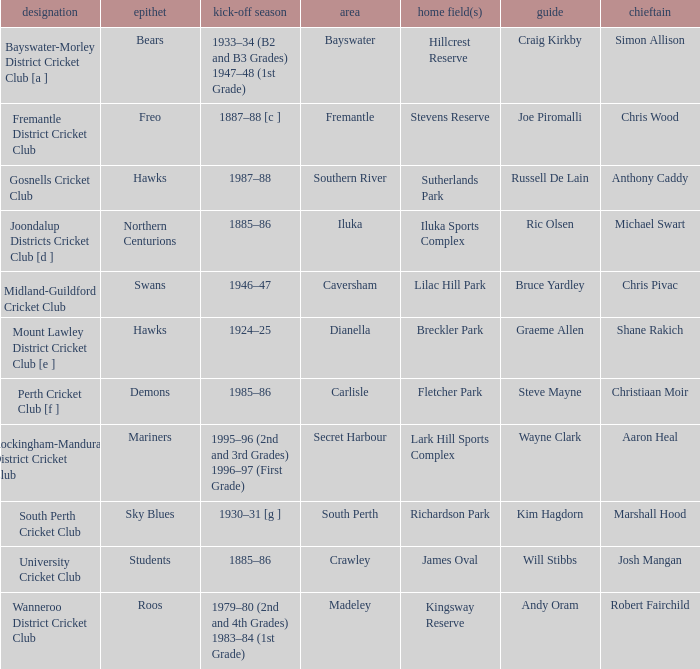What is the code nickname where Steve Mayne is the coach? Demons. 